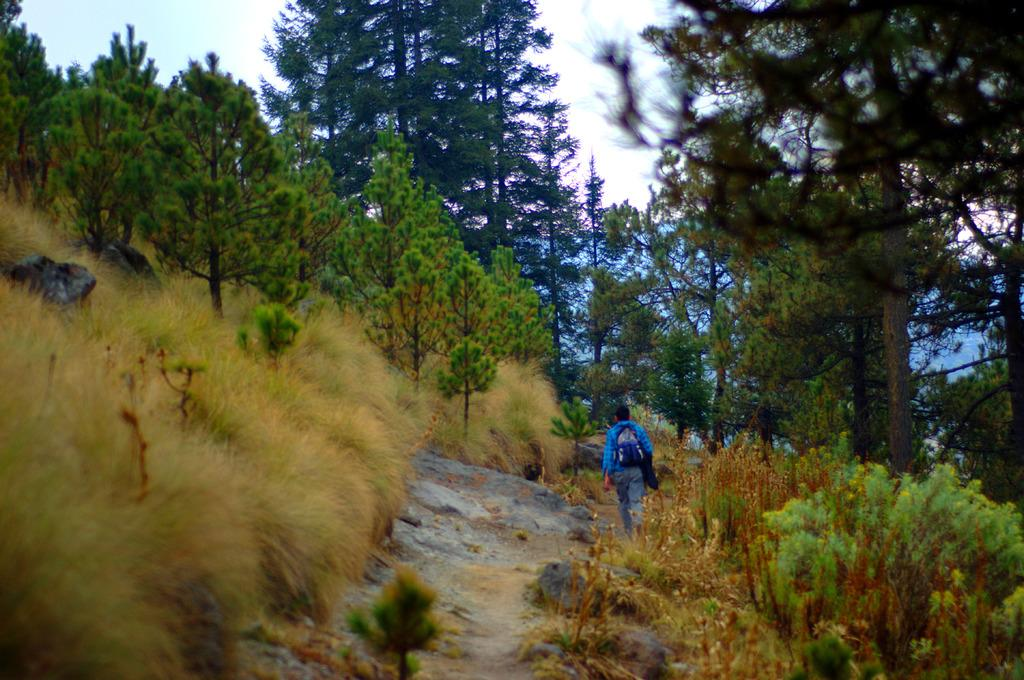What is the main subject of the image? There is a person walking in the middle of the image. What type of vegetation can be seen on either side of the image? There are trees on either side of the image. What is visible at the top of the image? The sky is visible at the top of the image. What type of lumber is being used to construct the buildings in the image? There are no buildings present in the image, only a person walking and trees on either side. What act is the person performing in the image? The image only shows a person walking, so it is not possible to determine any specific act they are performing. 